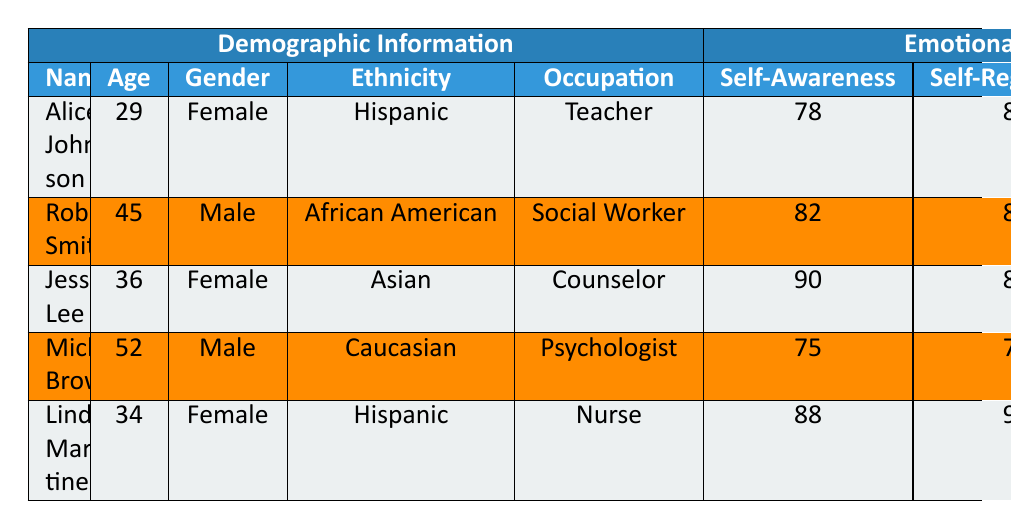What is the highest Emotional Intelligence score for Self-Awareness? Alice Johnson has a Self-Awareness score of 78, Robert Smith has 82, Jessica Lee has 90, Michael Brown has 75, and Linda Martinez has 88. The highest score among these is 90 (Jessica Lee).
Answer: 90 Who among the clients is the oldest? The ages listed are 29 (Alice Johnson), 45 (Robert Smith), 36 (Jessica Lee), 52 (Michael Brown), and 34 (Linda Martinez). Michael Brown, at 52 years old, is the oldest client.
Answer: Michael Brown What is the average Empathy score among the clients? The Empathy scores are 88 (Alice Johnson), 92 (Robert Smith), 95 (Jessica Lee), 80 (Michael Brown), and 89 (Linda Martinez). Summing these gives 88 + 92 + 95 + 80 + 89 = 444. There are 5 clients, so the average Empathy score is 444 / 5 = 88.8.
Answer: 88.8 Is Linda Martinez's Motivation score higher than her Self-Awareness score? Linda Martinez's Motivation score is 85 and her Self-Awareness score is 88. 85 is not higher than 88, so the statement is false.
Answer: No Which gender has the highest average score in Social Skills? The Social Skills scores are 75 (Alice Johnson, Female), 88 (Robert Smith, Male), 90 (Jessica Lee, Female), 85 (Michael Brown, Male), and 92 (Linda Martinez, Female). The average for females is (75 + 90 + 92) / 3 = 85.67 and for males (88 + 85) / 2 = 86.5. Since 86.5 > 85.67, males have the highest average score for Social Skills.
Answer: Male What is the difference between the highest and lowest Self-Regulation scores? The highest Self-Regulation score is 90 (Linda Martinez) and the lowest is 77 (Michael Brown). The difference is 90 - 77 = 13.
Answer: 13 Identify the client with the lowest score in Motivation. The Motivation scores are 90 (Alice Johnson), 70 (Robert Smith), 80 (Jessica Lee), 73 (Michael Brown), and 85 (Linda Martinez). Robert Smith has the lowest score of 70.
Answer: Robert Smith How many clients have a Self-Regulation score above 80? The Self-Regulation scores are 85 (Alice Johnson), 80 (Robert Smith), 85 (Jessica Lee), 77 (Michael Brown), and 90 (Linda Martinez). The clients with scores above 80 are Alice Johnson, Jessica Lee, and Linda Martinez, making a total of 3 clients.
Answer: 3 What percent of clients are Female? Out of 5 clients, 3 are Female (Alice Johnson, Jessica Lee, and Linda Martinez). The percentage of Female clients is (3 / 5) * 100 = 60%.
Answer: 60% What is the average age of all clients? The ages are 29 (Alice Johnson), 45 (Robert Smith), 36 (Jessica Lee), 52 (Michael Brown), and 34 (Linda Martinez). Their total age is 29 + 45 + 36 + 52 + 34 = 196, and the average age is 196 / 5 = 39.2.
Answer: 39.2 